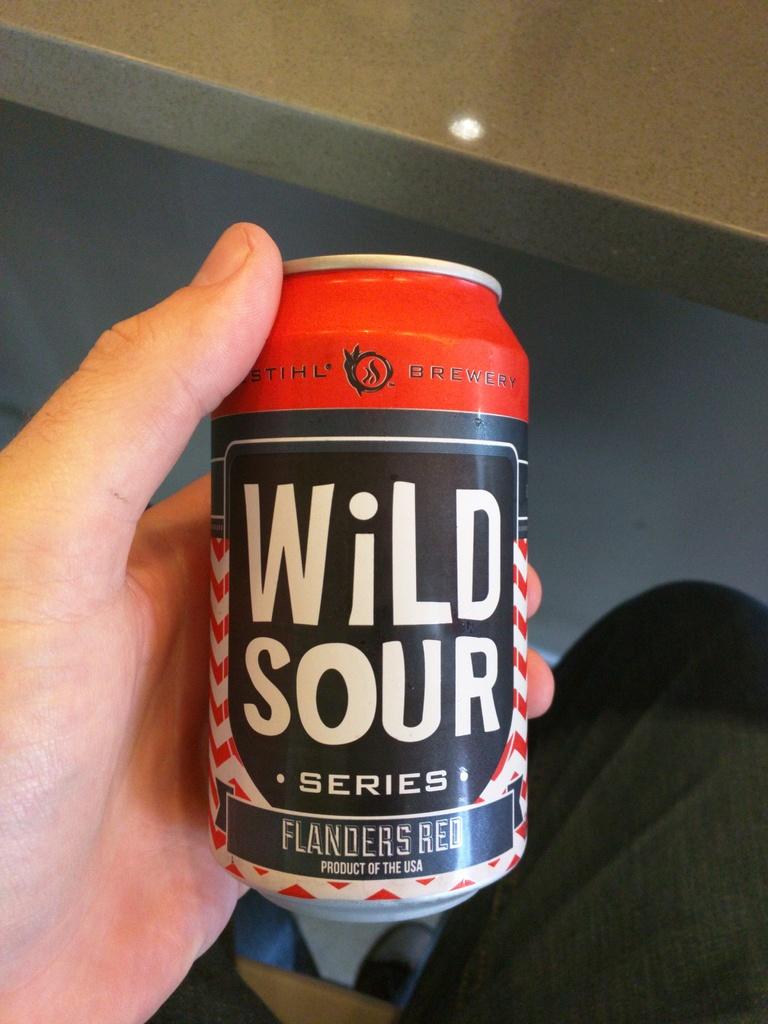What kind of red?
Provide a short and direct response. Flanders. 